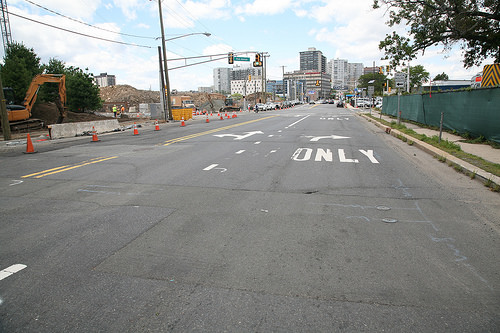<image>
Can you confirm if the sky is behind the building? Yes. From this viewpoint, the sky is positioned behind the building, with the building partially or fully occluding the sky. 